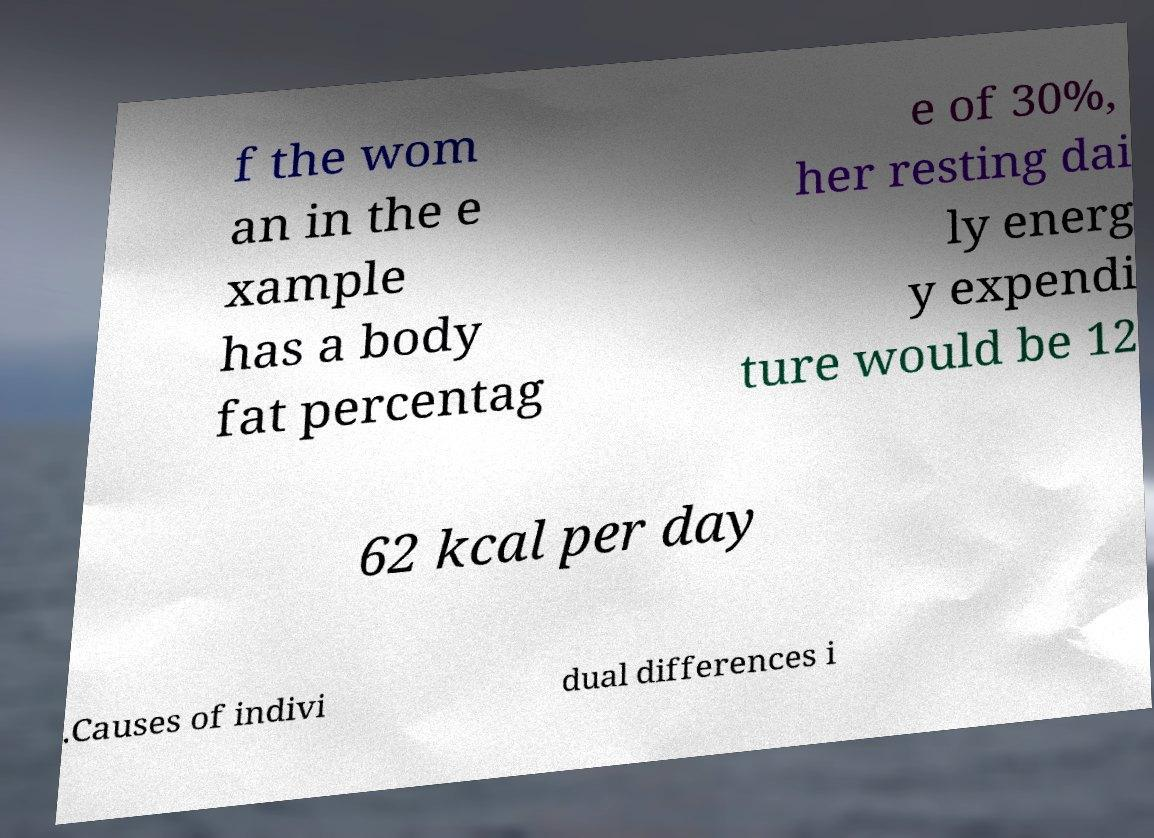Could you assist in decoding the text presented in this image and type it out clearly? f the wom an in the e xample has a body fat percentag e of 30%, her resting dai ly energ y expendi ture would be 12 62 kcal per day .Causes of indivi dual differences i 